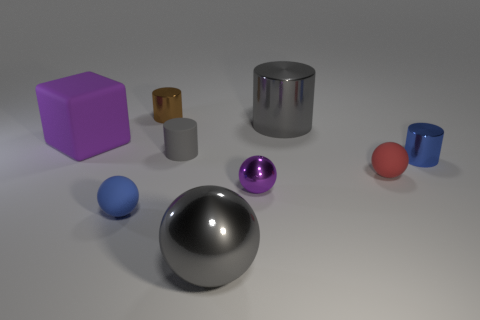Subtract all big gray metallic cylinders. How many cylinders are left? 3 Subtract all brown cylinders. How many cylinders are left? 3 Subtract 3 cylinders. How many cylinders are left? 1 Subtract all green balls. How many gray cylinders are left? 2 Subtract all cylinders. How many objects are left? 5 Subtract all gray cubes. Subtract all yellow cylinders. How many cubes are left? 1 Subtract all red objects. Subtract all tiny brown objects. How many objects are left? 7 Add 6 small blue shiny things. How many small blue shiny things are left? 7 Add 4 big purple spheres. How many big purple spheres exist? 4 Subtract 0 green cubes. How many objects are left? 9 